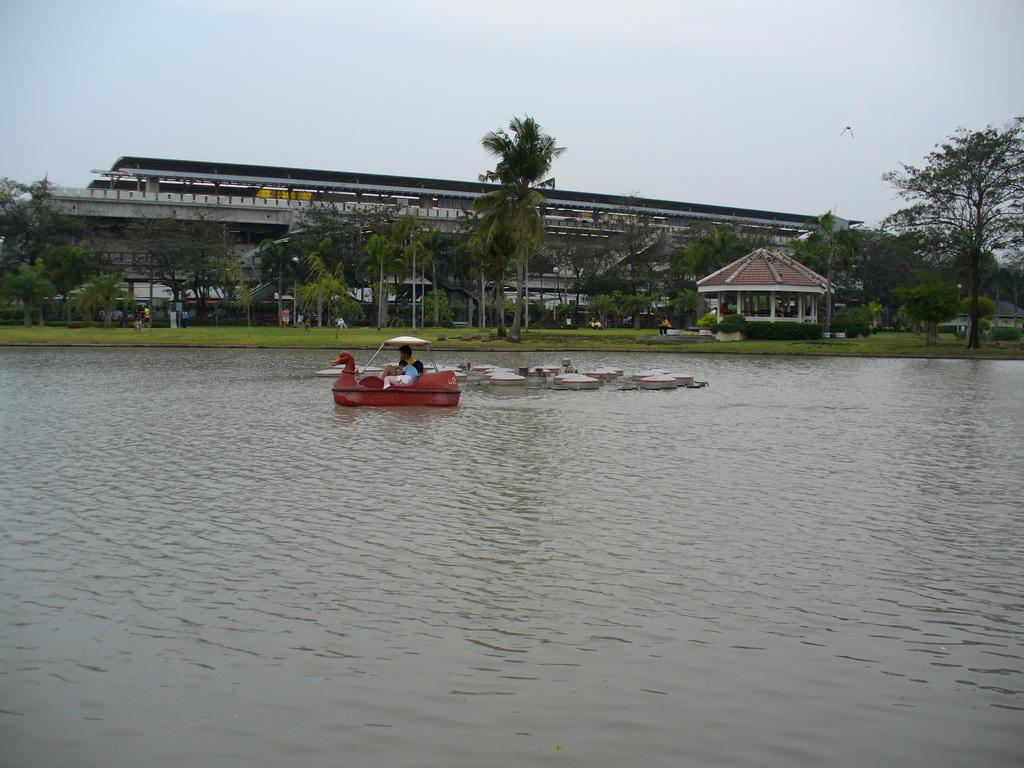What body of water is present in the image? There is a lake in the image. What is floating on the water in the image? There is a red color boat floating on the water. What can be seen in the background of the image? There are trees and a building in the background of the image. What part of the natural environment is visible in the image? The sky is visible in the background of the image. How many eyes can be seen on the horse in the image? There is no horse present in the image. What type of sponge is being used to clean the boat in the image? There is no sponge or cleaning activity depicted in the image. 